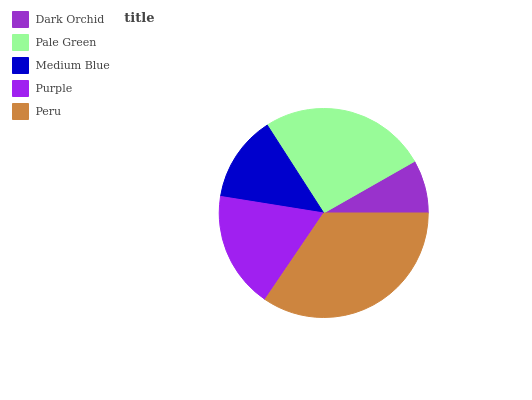Is Dark Orchid the minimum?
Answer yes or no. Yes. Is Peru the maximum?
Answer yes or no. Yes. Is Pale Green the minimum?
Answer yes or no. No. Is Pale Green the maximum?
Answer yes or no. No. Is Pale Green greater than Dark Orchid?
Answer yes or no. Yes. Is Dark Orchid less than Pale Green?
Answer yes or no. Yes. Is Dark Orchid greater than Pale Green?
Answer yes or no. No. Is Pale Green less than Dark Orchid?
Answer yes or no. No. Is Purple the high median?
Answer yes or no. Yes. Is Purple the low median?
Answer yes or no. Yes. Is Dark Orchid the high median?
Answer yes or no. No. Is Dark Orchid the low median?
Answer yes or no. No. 